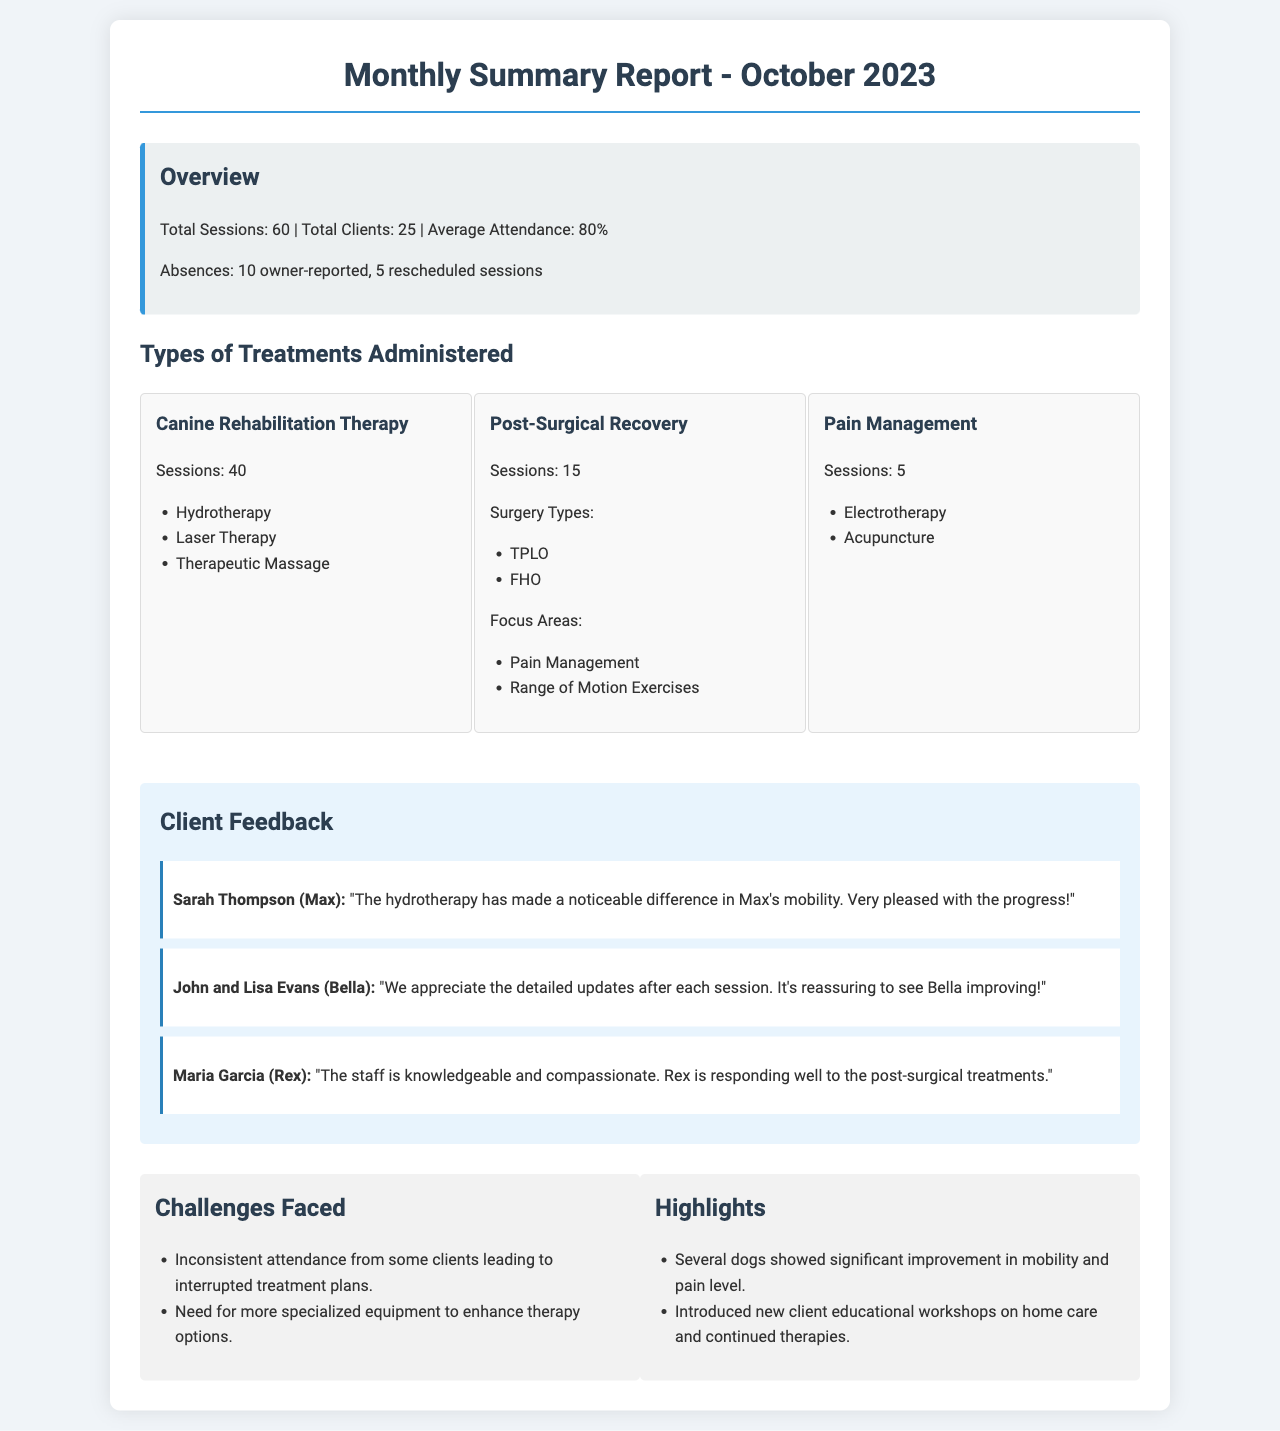What is the total number of sessions in October 2023? The total number of sessions listed in the report is found in the overview section of the document.
Answer: 60 How many clients attended the therapy sessions? The total number of clients is noted in the overview section.
Answer: 25 What is the average attendance percentage? The average attendance rate is detailed in the overview section.
Answer: 80% Which treatment had the highest number of sessions? The number of sessions for each type of treatment is listed; "Canine Rehabilitation Therapy" has the most sessions.
Answer: Canine Rehabilitation Therapy What two surgeries were focused on during post-surgical recovery? The surgeries are mentioned under the "Post-Surgical Recovery" treatment type.
Answer: TPLO and FHO What feedback did Sarah Thompson provide? Client feedback is provided in quotes, which summarize their experiences.
Answer: "The hydrotherapy has made a noticeable difference in Max's mobility. Very pleased with the progress!" What challenge was faced regarding client attendance? Challenges are listed in a specific section of the document.
Answer: Inconsistent attendance How many sessions were dedicated to pain management? The total number of sessions for pain management is stated under that treatment type.
Answer: 5 What was highlighted about the new client workshops? Highlights are summarized, noting improvements and new initiatives.
Answer: Introduced new client educational workshops on home care and continued therapies 